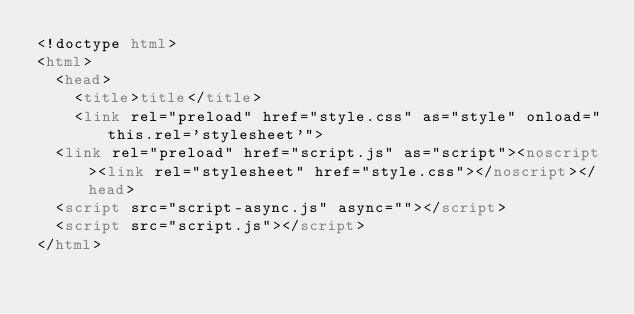<code> <loc_0><loc_0><loc_500><loc_500><_HTML_><!doctype html>
<html>
  <head>
    <title>title</title>
    <link rel="preload" href="style.css" as="style" onload="this.rel='stylesheet'">
  <link rel="preload" href="script.js" as="script"><noscript><link rel="stylesheet" href="style.css"></noscript></head>
  <script src="script-async.js" async=""></script>
  <script src="script.js"></script>
</html>
</code> 